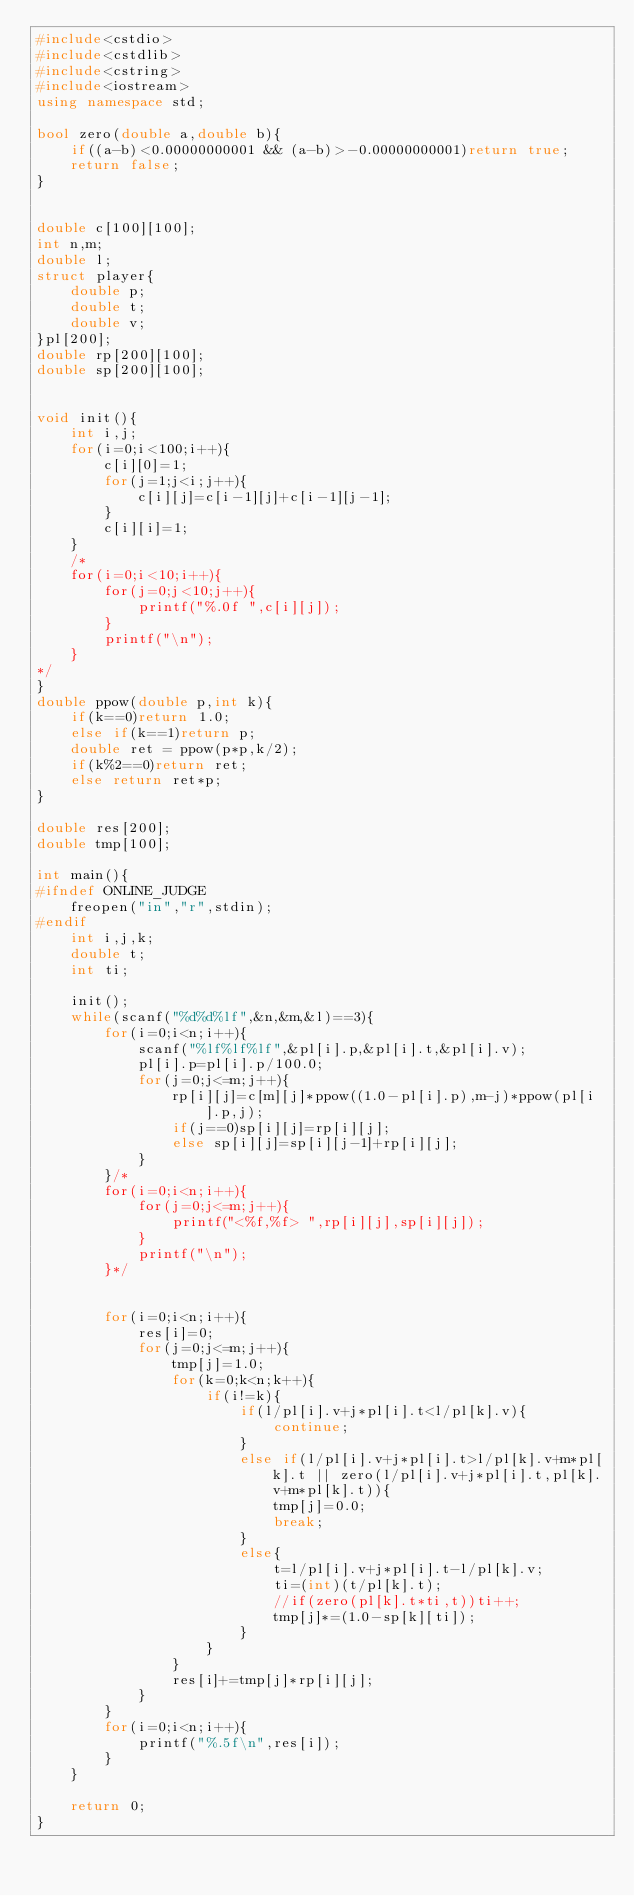<code> <loc_0><loc_0><loc_500><loc_500><_C++_>#include<cstdio>
#include<cstdlib>
#include<cstring>
#include<iostream>
using namespace std;

bool zero(double a,double b){
    if((a-b)<0.00000000001 && (a-b)>-0.00000000001)return true;
    return false;
}


double c[100][100];
int n,m;
double l;
struct player{
    double p;
    double t;
    double v;
}pl[200];
double rp[200][100];
double sp[200][100];


void init(){
    int i,j;
    for(i=0;i<100;i++){
        c[i][0]=1;
        for(j=1;j<i;j++){
            c[i][j]=c[i-1][j]+c[i-1][j-1];
        }
        c[i][i]=1;
    }
    /*
    for(i=0;i<10;i++){
        for(j=0;j<10;j++){
            printf("%.0f ",c[i][j]);
        }
        printf("\n");
    }
*/
}
double ppow(double p,int k){
    if(k==0)return 1.0;
    else if(k==1)return p;
    double ret = ppow(p*p,k/2);
    if(k%2==0)return ret;
    else return ret*p;
}

double res[200];
double tmp[100];

int main(){
#ifndef ONLINE_JUDGE
    freopen("in","r",stdin);
#endif
    int i,j,k;
    double t;
    int ti;

    init();
    while(scanf("%d%d%lf",&n,&m,&l)==3){
        for(i=0;i<n;i++){
            scanf("%lf%lf%lf",&pl[i].p,&pl[i].t,&pl[i].v);
            pl[i].p=pl[i].p/100.0;
            for(j=0;j<=m;j++){
                rp[i][j]=c[m][j]*ppow((1.0-pl[i].p),m-j)*ppow(pl[i].p,j);
                if(j==0)sp[i][j]=rp[i][j];
                else sp[i][j]=sp[i][j-1]+rp[i][j];
            }
        }/*
        for(i=0;i<n;i++){
            for(j=0;j<=m;j++){
                printf("<%f,%f> ",rp[i][j],sp[i][j]);
            }
            printf("\n");
        }*/
        

        for(i=0;i<n;i++){
            res[i]=0;
            for(j=0;j<=m;j++){
                tmp[j]=1.0;
                for(k=0;k<n;k++){
                    if(i!=k){
                        if(l/pl[i].v+j*pl[i].t<l/pl[k].v){
                            continue;
                        }
                        else if(l/pl[i].v+j*pl[i].t>l/pl[k].v+m*pl[k].t || zero(l/pl[i].v+j*pl[i].t,pl[k].v+m*pl[k].t)){
                            tmp[j]=0.0;
                            break;
                        }
                        else{
                            t=l/pl[i].v+j*pl[i].t-l/pl[k].v;
                            ti=(int)(t/pl[k].t);
                            //if(zero(pl[k].t*ti,t))ti++;
                            tmp[j]*=(1.0-sp[k][ti]);
                        }
                    }
                }
                res[i]+=tmp[j]*rp[i][j];
            }
        }
        for(i=0;i<n;i++){
            printf("%.5f\n",res[i]);
        }
    }

    return 0;
}</code> 